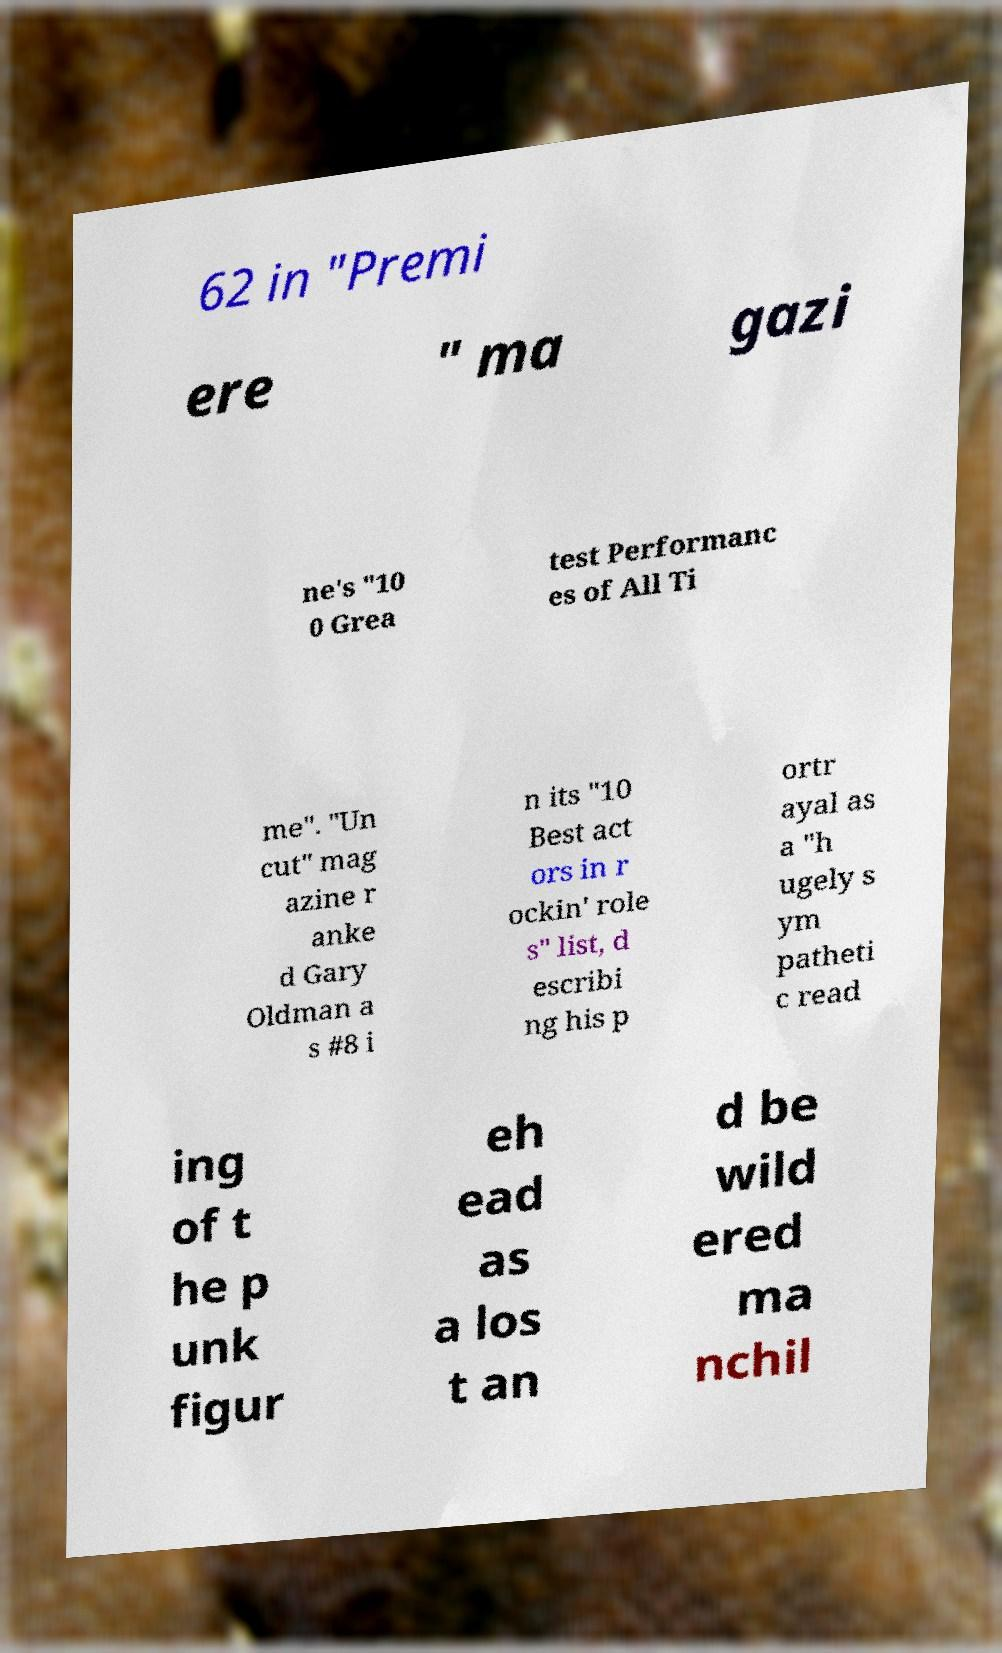I need the written content from this picture converted into text. Can you do that? 62 in "Premi ere " ma gazi ne's "10 0 Grea test Performanc es of All Ti me". "Un cut" mag azine r anke d Gary Oldman a s #8 i n its "10 Best act ors in r ockin' role s" list, d escribi ng his p ortr ayal as a "h ugely s ym patheti c read ing of t he p unk figur eh ead as a los t an d be wild ered ma nchil 